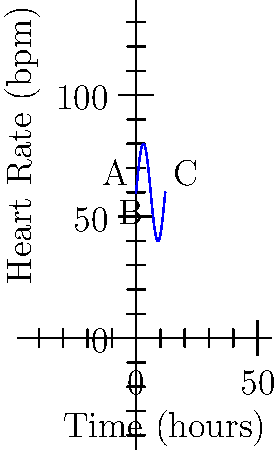The graph shows your heart rate (in beats per minute) over a 12-hour period during an experiment. At which point (A, B, or C) is your heart rate changing most rapidly? Justify your answer using calculus concepts. To determine where the heart rate is changing most rapidly, we need to analyze the derivative of the function at points A, B, and C. The derivative represents the rate of change.

1. Point A (t = 0):
   The slope of the tangent line is positive and steep.
   
2. Point B (t = 6):
   The slope of the tangent line is zero, as it's at a local maximum.
   
3. Point C (t = 12):
   The slope of the tangent line is positive but less steep than at point A.

The derivative of the function $f(t) = 60 + 20\sin(\frac{\pi t}{6})$ is:

$$f'(t) = 20 \cdot \frac{\pi}{6} \cos(\frac{\pi t}{6})$$

The absolute value of this derivative will be largest when $\cos(\frac{\pi t}{6})$ is at its maximum, which occurs at t = 0 (point A) and t = 12 (point C).

However, $|f'(0)| = |\frac{10\pi}{3}| \approx 10.47$ is greater than $|f'(12)| = |-\frac{10\pi}{3}| \approx 10.47$.

Therefore, the heart rate is changing most rapidly at point A.
Answer: Point A 